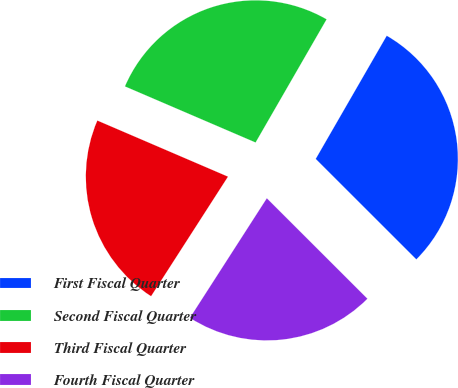Convert chart to OTSL. <chart><loc_0><loc_0><loc_500><loc_500><pie_chart><fcel>First Fiscal Quarter<fcel>Second Fiscal Quarter<fcel>Third Fiscal Quarter<fcel>Fourth Fiscal Quarter<nl><fcel>29.17%<fcel>26.87%<fcel>22.36%<fcel>21.61%<nl></chart> 